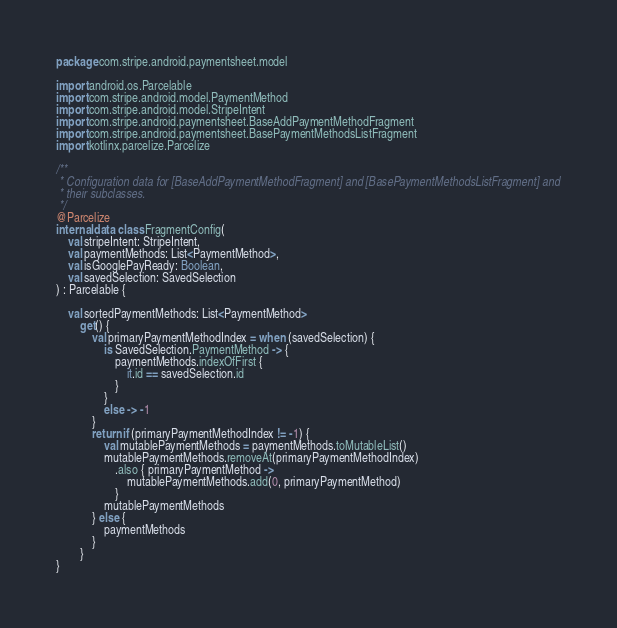<code> <loc_0><loc_0><loc_500><loc_500><_Kotlin_>package com.stripe.android.paymentsheet.model

import android.os.Parcelable
import com.stripe.android.model.PaymentMethod
import com.stripe.android.model.StripeIntent
import com.stripe.android.paymentsheet.BaseAddPaymentMethodFragment
import com.stripe.android.paymentsheet.BasePaymentMethodsListFragment
import kotlinx.parcelize.Parcelize

/**
 * Configuration data for [BaseAddPaymentMethodFragment] and [BasePaymentMethodsListFragment] and
 * their subclasses.
 */
@Parcelize
internal data class FragmentConfig(
    val stripeIntent: StripeIntent,
    val paymentMethods: List<PaymentMethod>,
    val isGooglePayReady: Boolean,
    val savedSelection: SavedSelection
) : Parcelable {

    val sortedPaymentMethods: List<PaymentMethod>
        get() {
            val primaryPaymentMethodIndex = when (savedSelection) {
                is SavedSelection.PaymentMethod -> {
                    paymentMethods.indexOfFirst {
                        it.id == savedSelection.id
                    }
                }
                else -> -1
            }
            return if (primaryPaymentMethodIndex != -1) {
                val mutablePaymentMethods = paymentMethods.toMutableList()
                mutablePaymentMethods.removeAt(primaryPaymentMethodIndex)
                    .also { primaryPaymentMethod ->
                        mutablePaymentMethods.add(0, primaryPaymentMethod)
                    }
                mutablePaymentMethods
            } else {
                paymentMethods
            }
        }
}
</code> 